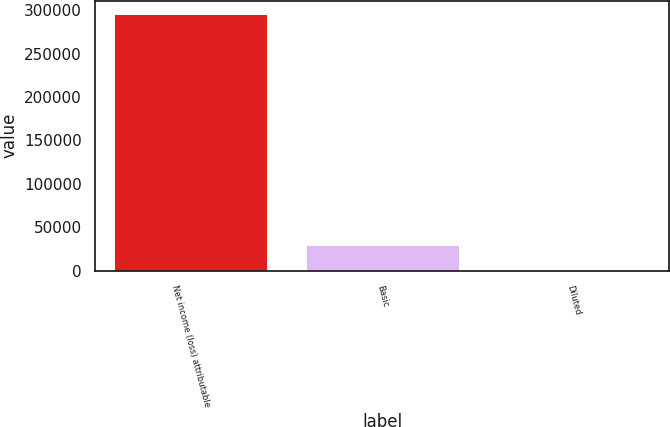Convert chart to OTSL. <chart><loc_0><loc_0><loc_500><loc_500><bar_chart><fcel>Net income (loss) attributable<fcel>Basic<fcel>Diluted<nl><fcel>295864<fcel>29587.2<fcel>0.94<nl></chart> 